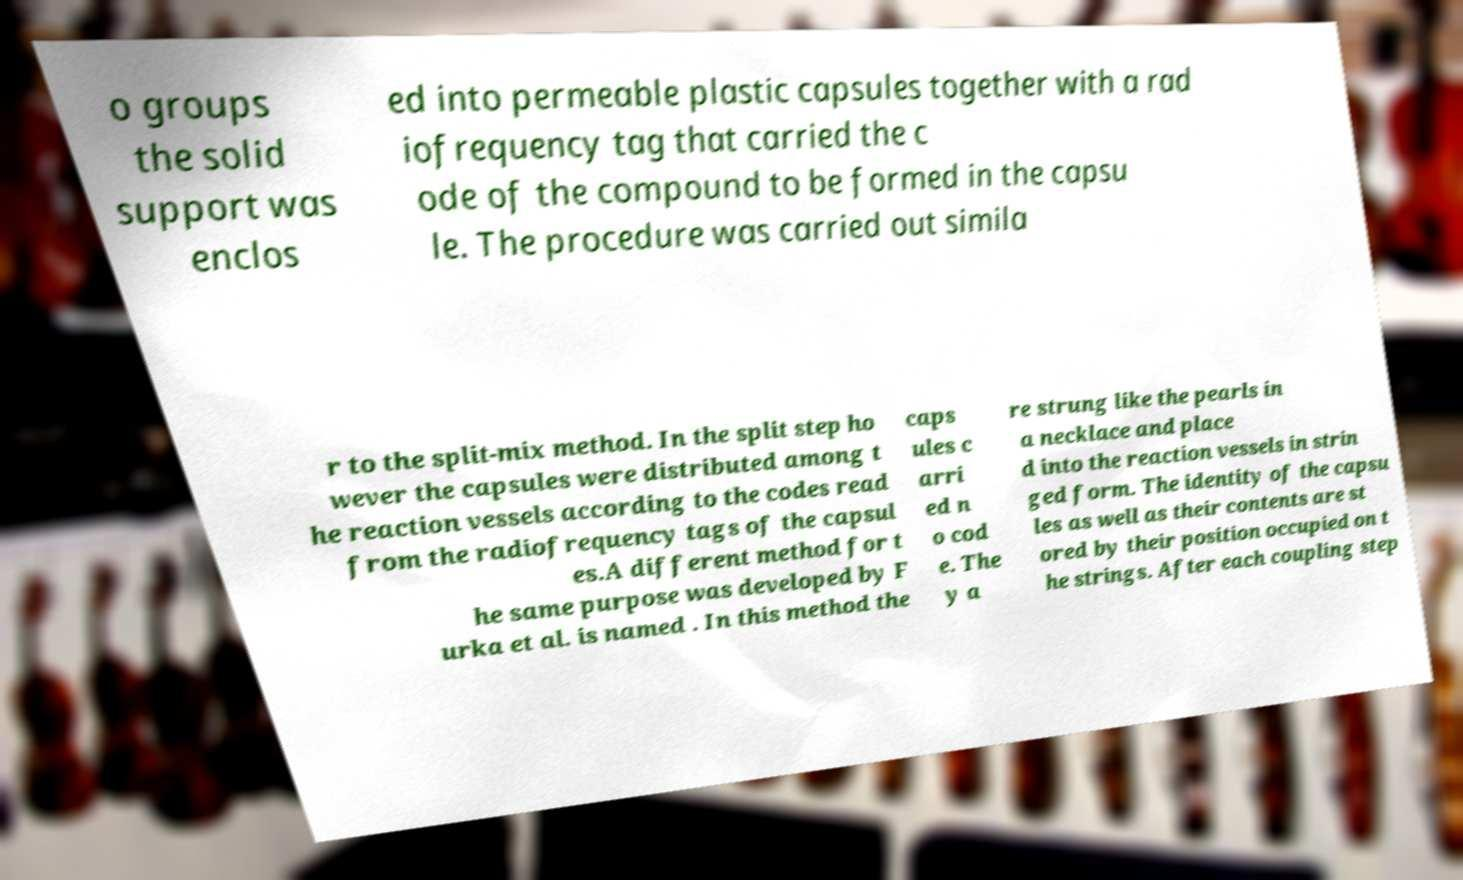Can you read and provide the text displayed in the image?This photo seems to have some interesting text. Can you extract and type it out for me? o groups the solid support was enclos ed into permeable plastic capsules together with a rad iofrequency tag that carried the c ode of the compound to be formed in the capsu le. The procedure was carried out simila r to the split-mix method. In the split step ho wever the capsules were distributed among t he reaction vessels according to the codes read from the radiofrequency tags of the capsul es.A different method for t he same purpose was developed by F urka et al. is named . In this method the caps ules c arri ed n o cod e. The y a re strung like the pearls in a necklace and place d into the reaction vessels in strin ged form. The identity of the capsu les as well as their contents are st ored by their position occupied on t he strings. After each coupling step 